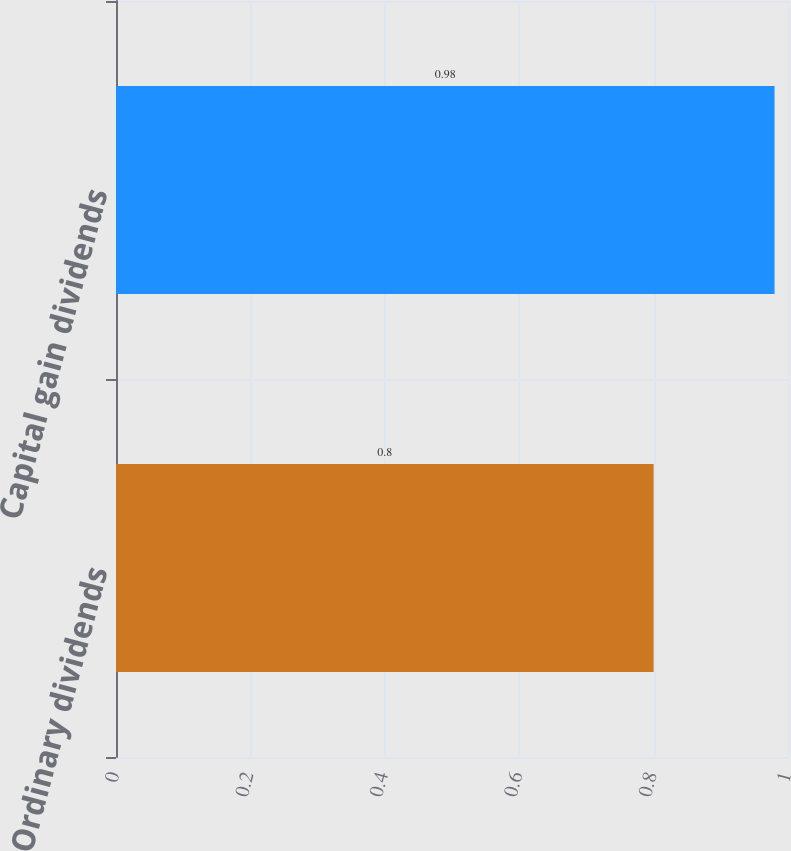<chart> <loc_0><loc_0><loc_500><loc_500><bar_chart><fcel>Ordinary dividends<fcel>Capital gain dividends<nl><fcel>0.8<fcel>0.98<nl></chart> 